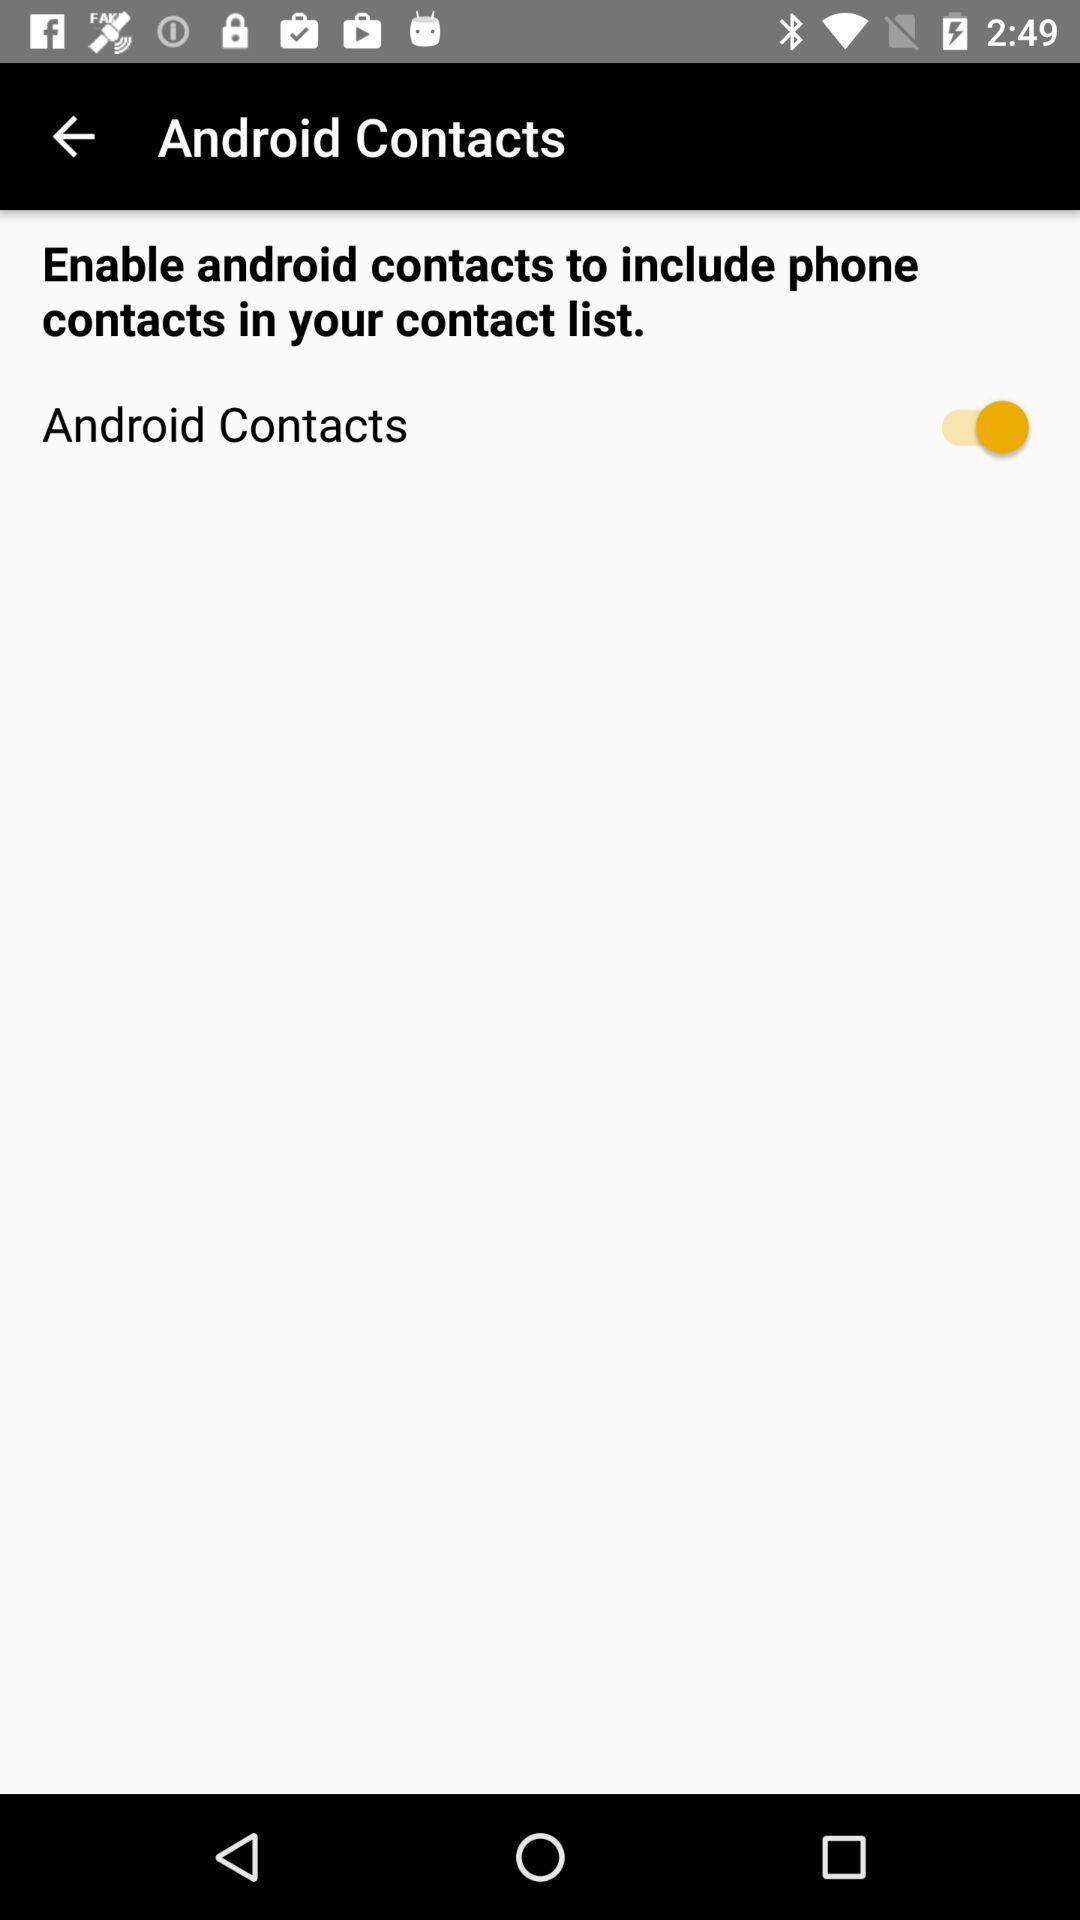Summarize the information in this screenshot. Page to enable the contact option in the voice app. 